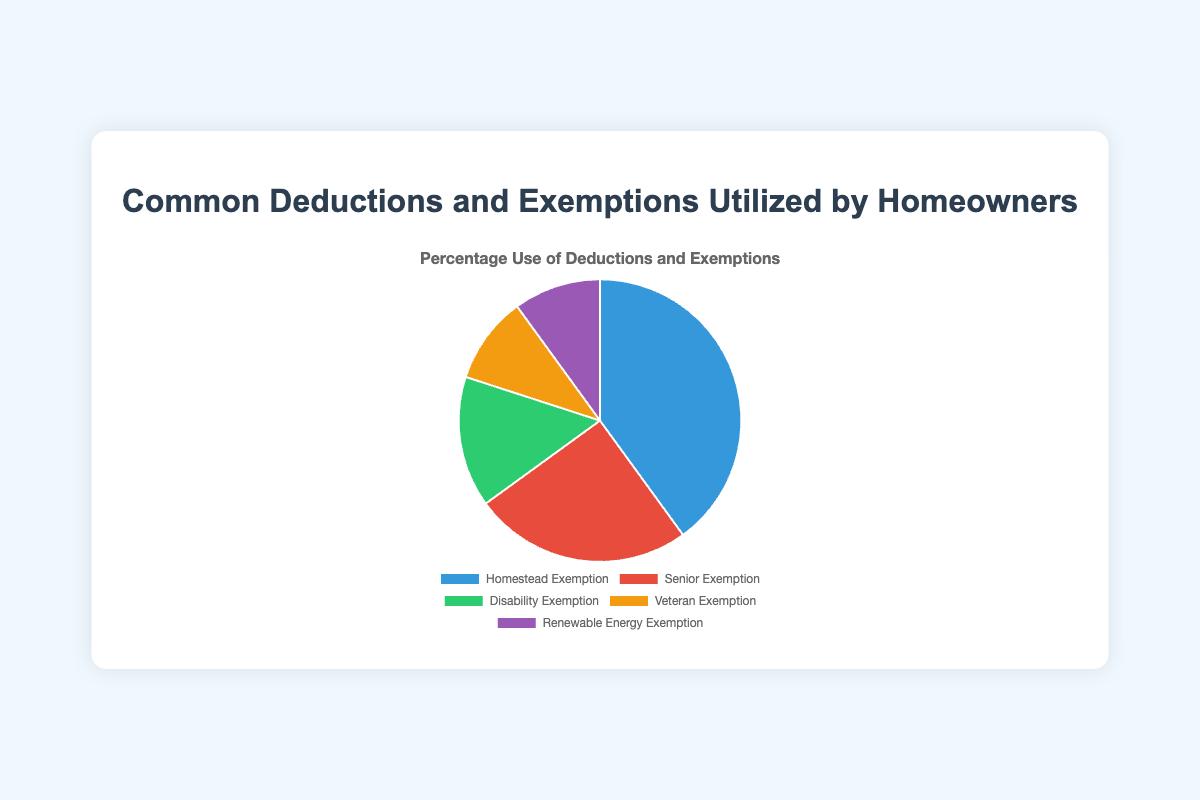What's the most common deduction or exemption utilized by homeowners? The Homestead Exemption has the largest portion in the pie chart, representing 40% of the total.
Answer: Homestead Exemption What percentage of homeowners utilize either the Veteran Exemption or the Renewable Energy Exemption? The portions for Veteran Exemption and Renewable Energy Exemption are 10% each, so adding them results in 10% + 10% = 20%.
Answer: 20% How much more popular is the Homestead Exemption compared to the Disability Exemption? The Homestead Exemption is utilized by 40% of homeowners, whereas the Disability Exemption is utilized by 15%. The difference is 40% - 15% = 25%.
Answer: 25% Which two exemptions combined are utilized by an equal percentage of homeowners as the Senior Exemption? The senior exemption is utilized by 25% of homeowners. The Disability and Veteran Exemptions both add up to 15% + 10% = 25%, which matches the Senior Exemption.
Answer: Disability Exemption and Veteran Exemption What color represents the exemption with the lowest percentage use? Both the Veteran Exemption and the Renewable Energy Exemption are represented by 10%. The visual representation uses yellow for the Veteran Exemption and purple for the Renewable Energy Exemption.
Answer: Yellow and Purple Is the percentage of homeowners utilizing the Disability Exemption greater or less than those utilizing the Senior Exemption? The Disability Exemption is utilized by 15% of homeowners, which is less than the Senior Exemption utilized by 25%.
Answer: Less What percentage of homeowners utilize either the Homestead Exemption or the Senior Exemption? The Homestead Exemption is utilized by 40% and the Senior Exemption by 25%, so the total is 40% + 25% = 65%.
Answer: 65% By what factor is the percentage of Homestead Exemption users larger than the Renewable Energy Exemption users? The Homestead Exemption is utilized by 40% of homeowners and the Renewable Energy Exemption by 10%. The factor is calculated by dividing these percentages: 40% / 10% = 4.
Answer: 4 What is the combined percentage use of the Disabilities Exemption and Renewable Energy Exemption? The Disabilities Exemption is utilized by 15% of homeowners, and the Renewable Energy Exemption by 10%. The combined percentage is 15% + 10% = 25%.
Answer: 25% 